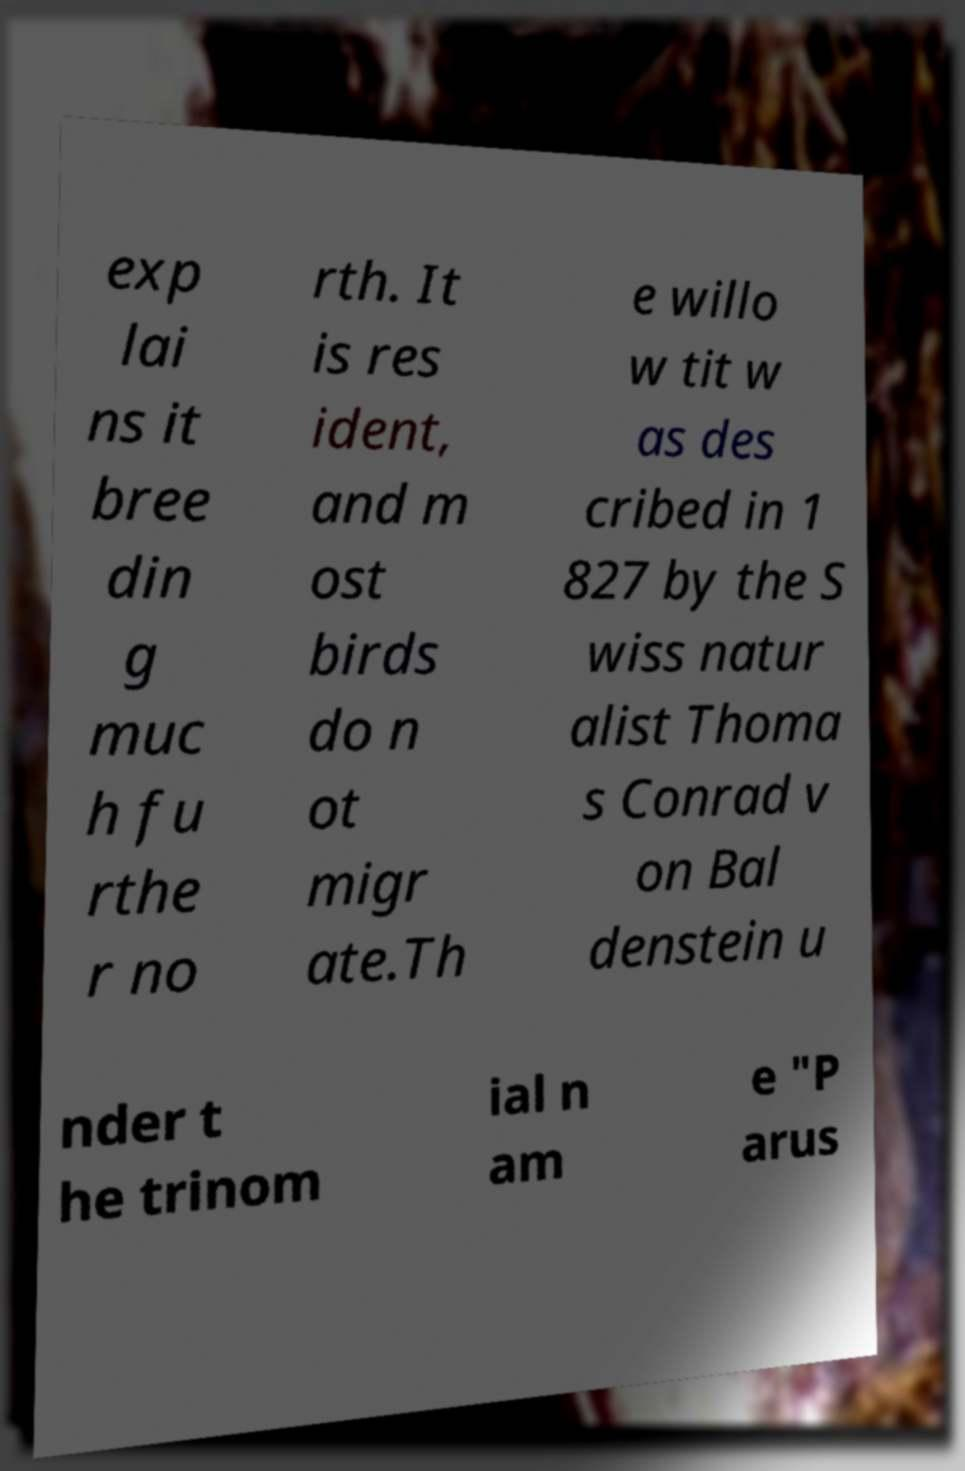For documentation purposes, I need the text within this image transcribed. Could you provide that? exp lai ns it bree din g muc h fu rthe r no rth. It is res ident, and m ost birds do n ot migr ate.Th e willo w tit w as des cribed in 1 827 by the S wiss natur alist Thoma s Conrad v on Bal denstein u nder t he trinom ial n am e "P arus 